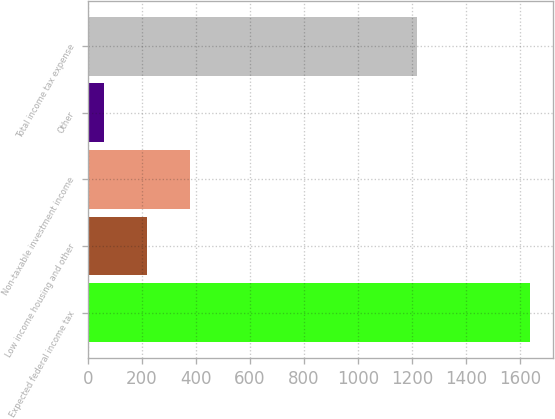<chart> <loc_0><loc_0><loc_500><loc_500><bar_chart><fcel>Expected federal income tax<fcel>Low income housing and other<fcel>Non-taxable investment income<fcel>Other<fcel>Total income tax expense<nl><fcel>1639<fcel>217.9<fcel>375.8<fcel>60<fcel>1220<nl></chart> 